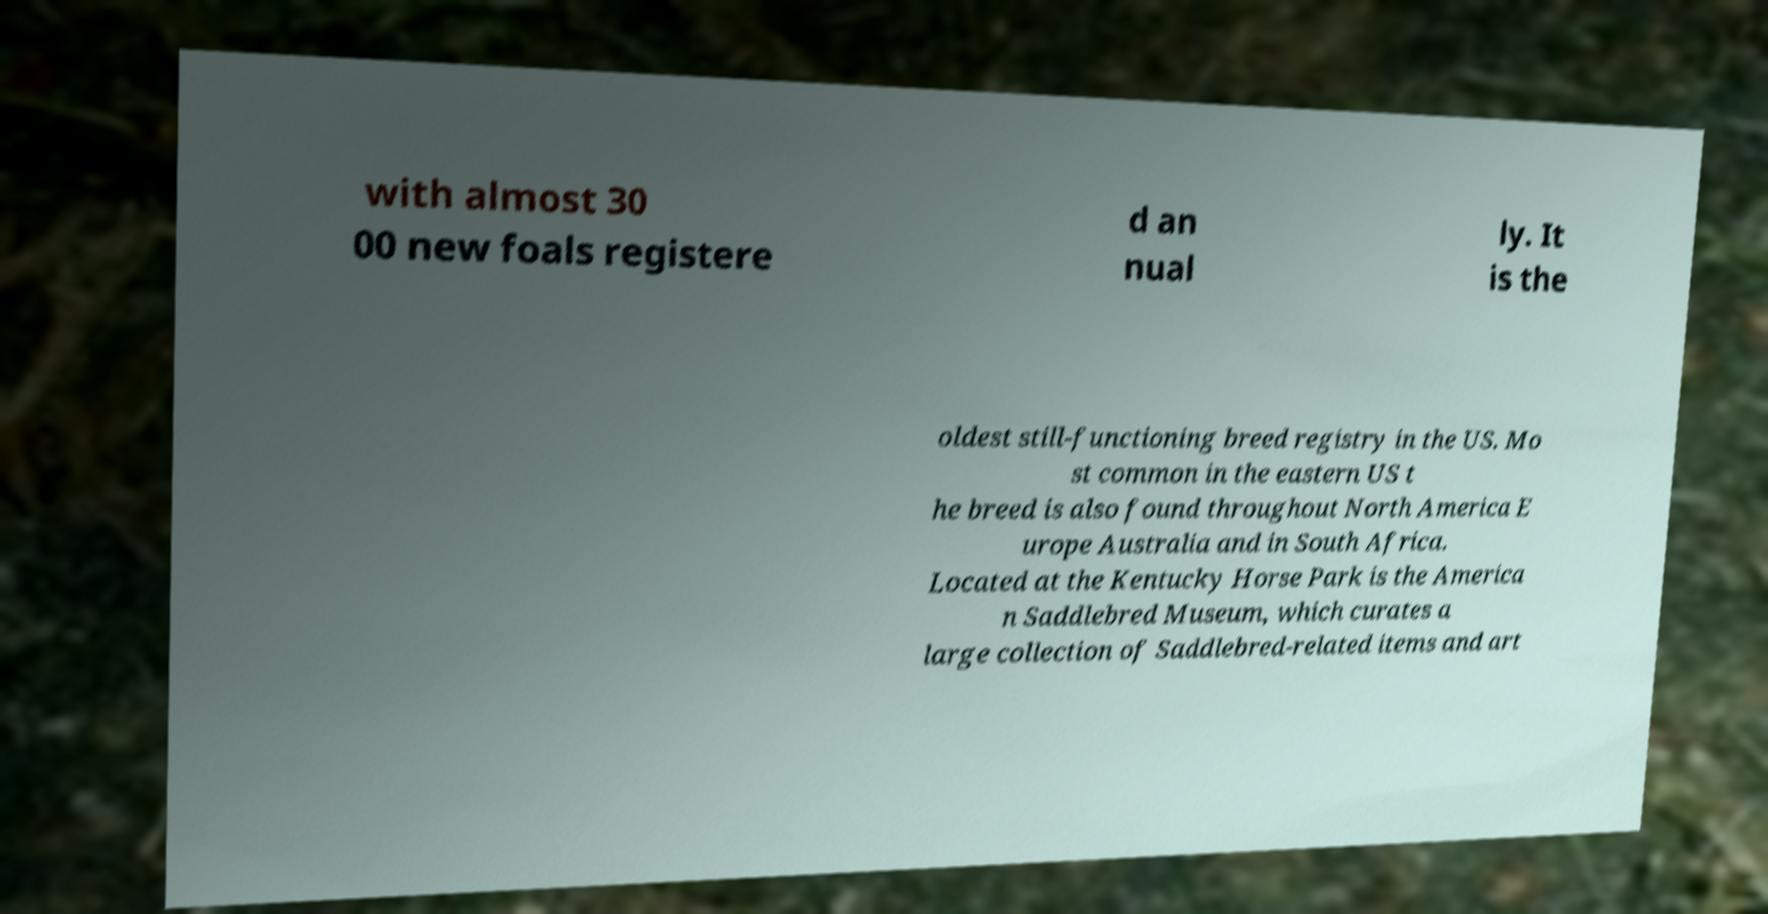What messages or text are displayed in this image? I need them in a readable, typed format. with almost 30 00 new foals registere d an nual ly. It is the oldest still-functioning breed registry in the US. Mo st common in the eastern US t he breed is also found throughout North America E urope Australia and in South Africa. Located at the Kentucky Horse Park is the America n Saddlebred Museum, which curates a large collection of Saddlebred-related items and art 